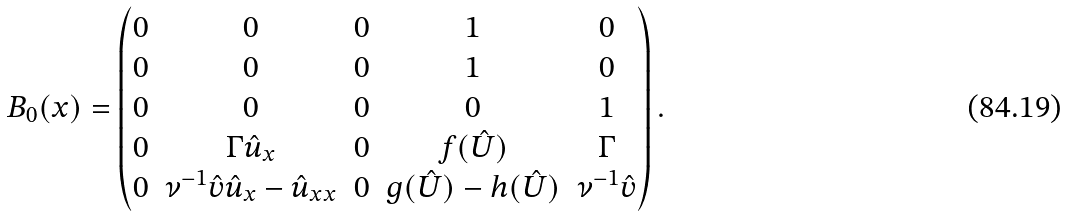<formula> <loc_0><loc_0><loc_500><loc_500>B _ { 0 } ( x ) = \begin{pmatrix} 0 & 0 & 0 & 1 & 0 \\ 0 & 0 & 0 & 1 & 0 \\ 0 & 0 & 0 & 0 & 1 \\ 0 & \Gamma \hat { u } _ { x } & 0 & f ( \hat { U } ) & \Gamma \\ 0 & \nu ^ { - 1 } \hat { v } \hat { u } _ { x } - \hat { u } _ { x x } & 0 & g ( \hat { U } ) - h ( \hat { U } ) & \nu ^ { - 1 } \hat { v } \\ \end{pmatrix} .</formula> 